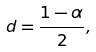Convert formula to latex. <formula><loc_0><loc_0><loc_500><loc_500>d = \frac { 1 - \alpha } { 2 } ,</formula> 